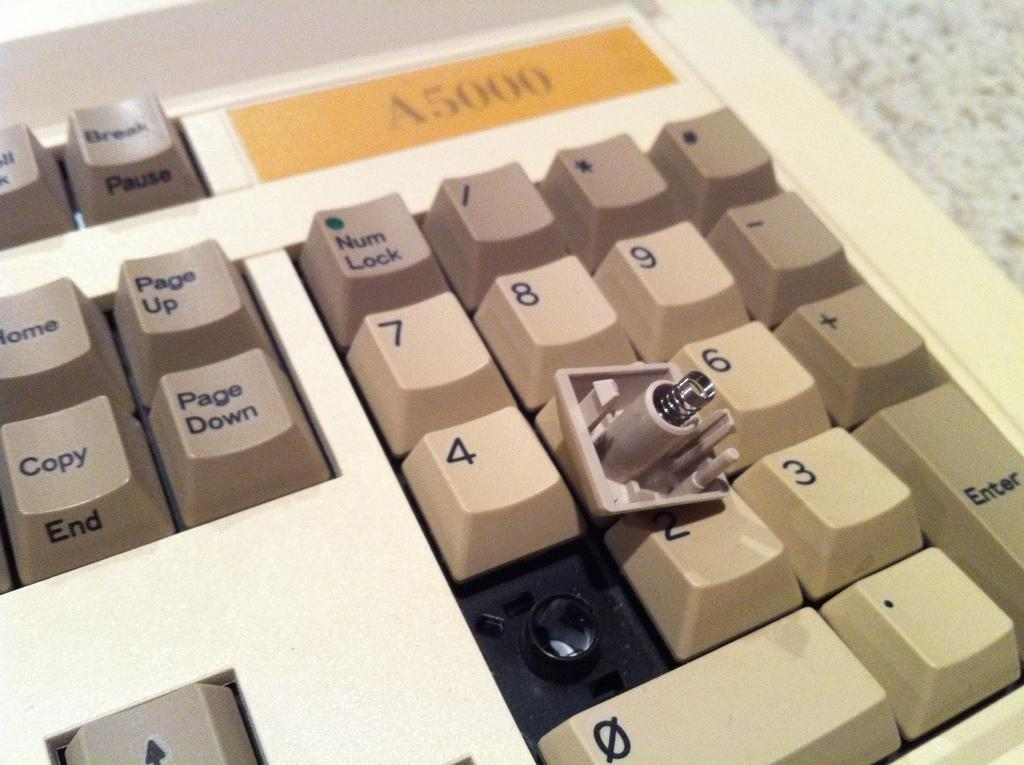Provide a one-sentence caption for the provided image. The number 1 key cap is lying upside down on a number keypad. 